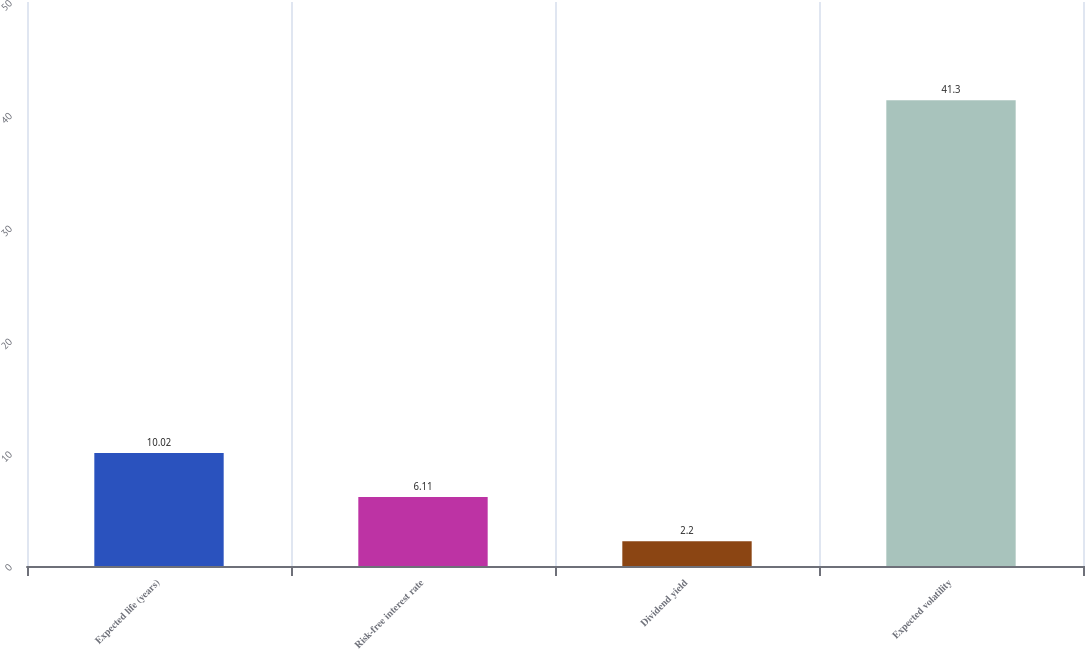Convert chart to OTSL. <chart><loc_0><loc_0><loc_500><loc_500><bar_chart><fcel>Expected life (years)<fcel>Risk-free interest rate<fcel>Dividend yield<fcel>Expected volatility<nl><fcel>10.02<fcel>6.11<fcel>2.2<fcel>41.3<nl></chart> 